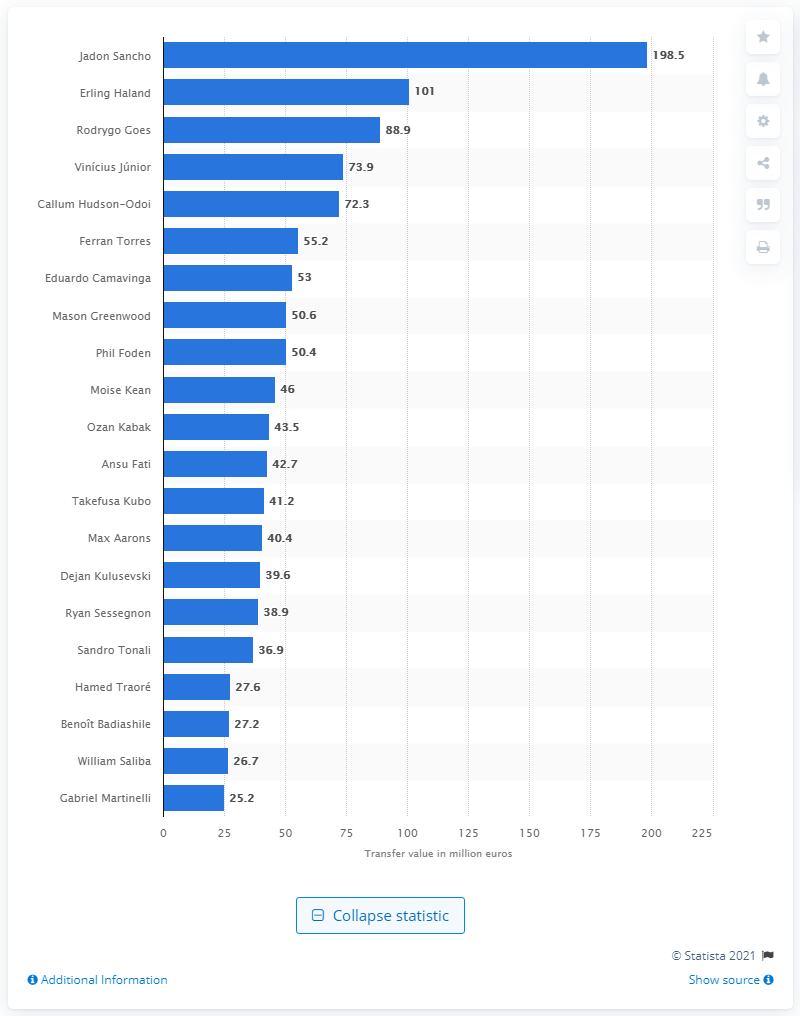Highlight a few significant elements in this photo. In March 2020, Jadon Sancho was valued at 198.5... 